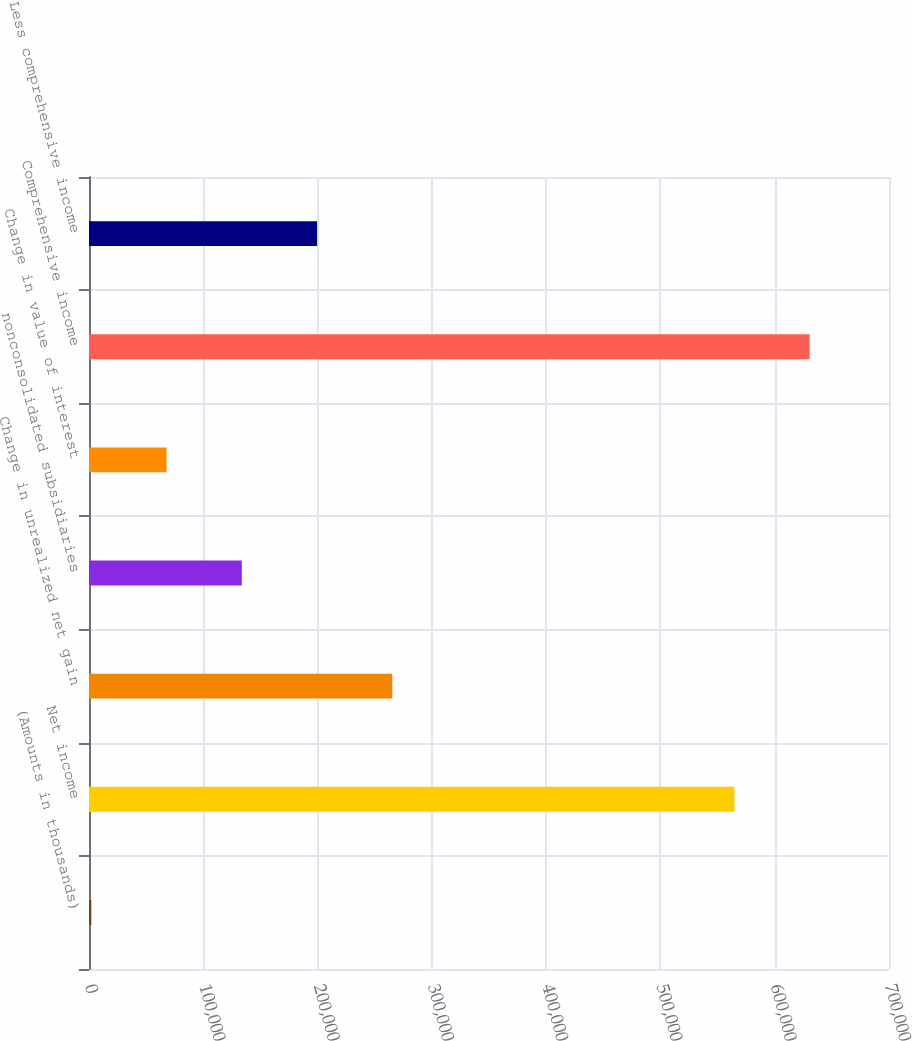<chart> <loc_0><loc_0><loc_500><loc_500><bar_chart><fcel>(Amounts in thousands)<fcel>Net income<fcel>Change in unrealized net gain<fcel>nonconsolidated subsidiaries<fcel>Change in value of interest<fcel>Comprehensive income<fcel>Less comprehensive income<nl><fcel>2013<fcel>564740<fcel>265415<fcel>133714<fcel>67863.6<fcel>630591<fcel>199565<nl></chart> 